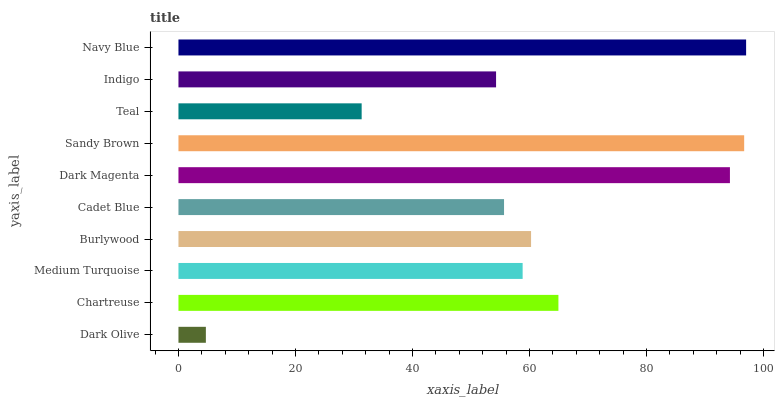Is Dark Olive the minimum?
Answer yes or no. Yes. Is Navy Blue the maximum?
Answer yes or no. Yes. Is Chartreuse the minimum?
Answer yes or no. No. Is Chartreuse the maximum?
Answer yes or no. No. Is Chartreuse greater than Dark Olive?
Answer yes or no. Yes. Is Dark Olive less than Chartreuse?
Answer yes or no. Yes. Is Dark Olive greater than Chartreuse?
Answer yes or no. No. Is Chartreuse less than Dark Olive?
Answer yes or no. No. Is Burlywood the high median?
Answer yes or no. Yes. Is Medium Turquoise the low median?
Answer yes or no. Yes. Is Medium Turquoise the high median?
Answer yes or no. No. Is Sandy Brown the low median?
Answer yes or no. No. 